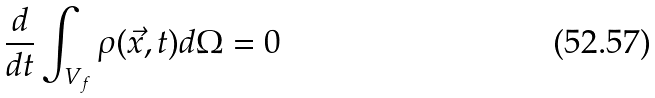Convert formula to latex. <formula><loc_0><loc_0><loc_500><loc_500>\frac { d } { d t } \int _ { V _ { f } } \rho ( \vec { x } , t ) d \Omega = 0</formula> 